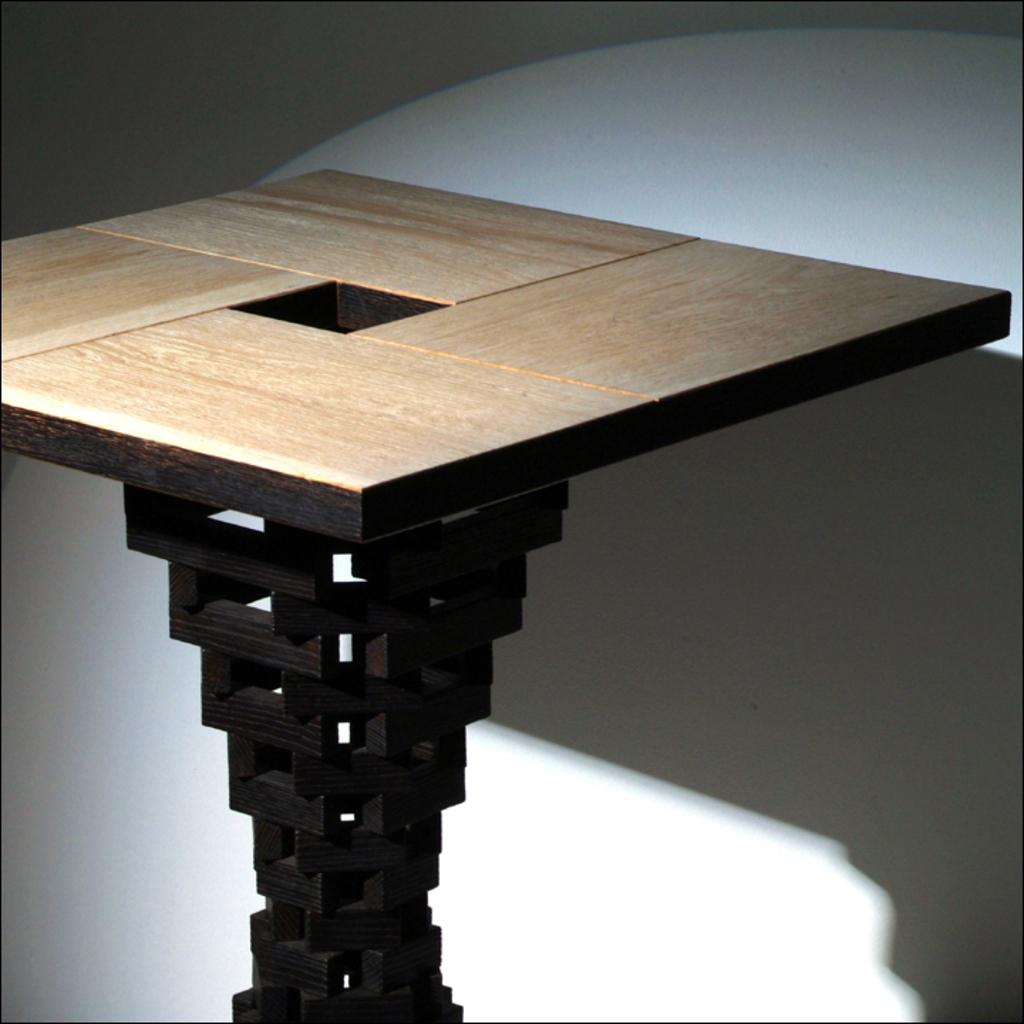What is the color of the table in the image? The table in the image is brown. What can be seen in the background of the image? There is a wall in the background of the image. What is the color of the wall in the image? The wall in the image is white. How does the sense of anger manifest in the image? There is no indication of anger or any emotions in the image, as it only features a brown table and a white wall. 